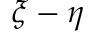Convert formula to latex. <formula><loc_0><loc_0><loc_500><loc_500>\xi - \eta</formula> 